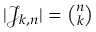Convert formula to latex. <formula><loc_0><loc_0><loc_500><loc_500>| { \mathcal { J } } _ { k , n } | = { \binom { n } { k } }</formula> 